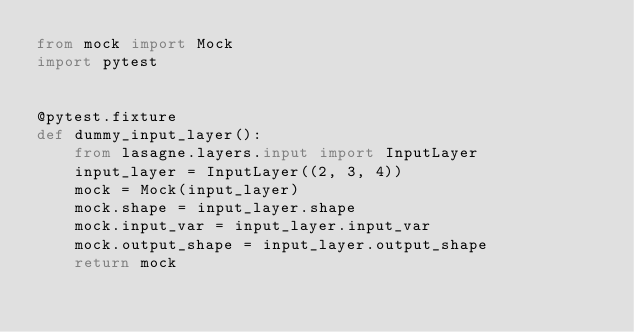<code> <loc_0><loc_0><loc_500><loc_500><_Python_>from mock import Mock
import pytest


@pytest.fixture
def dummy_input_layer():
    from lasagne.layers.input import InputLayer
    input_layer = InputLayer((2, 3, 4))
    mock = Mock(input_layer)
    mock.shape = input_layer.shape
    mock.input_var = input_layer.input_var
    mock.output_shape = input_layer.output_shape
    return mock
</code> 